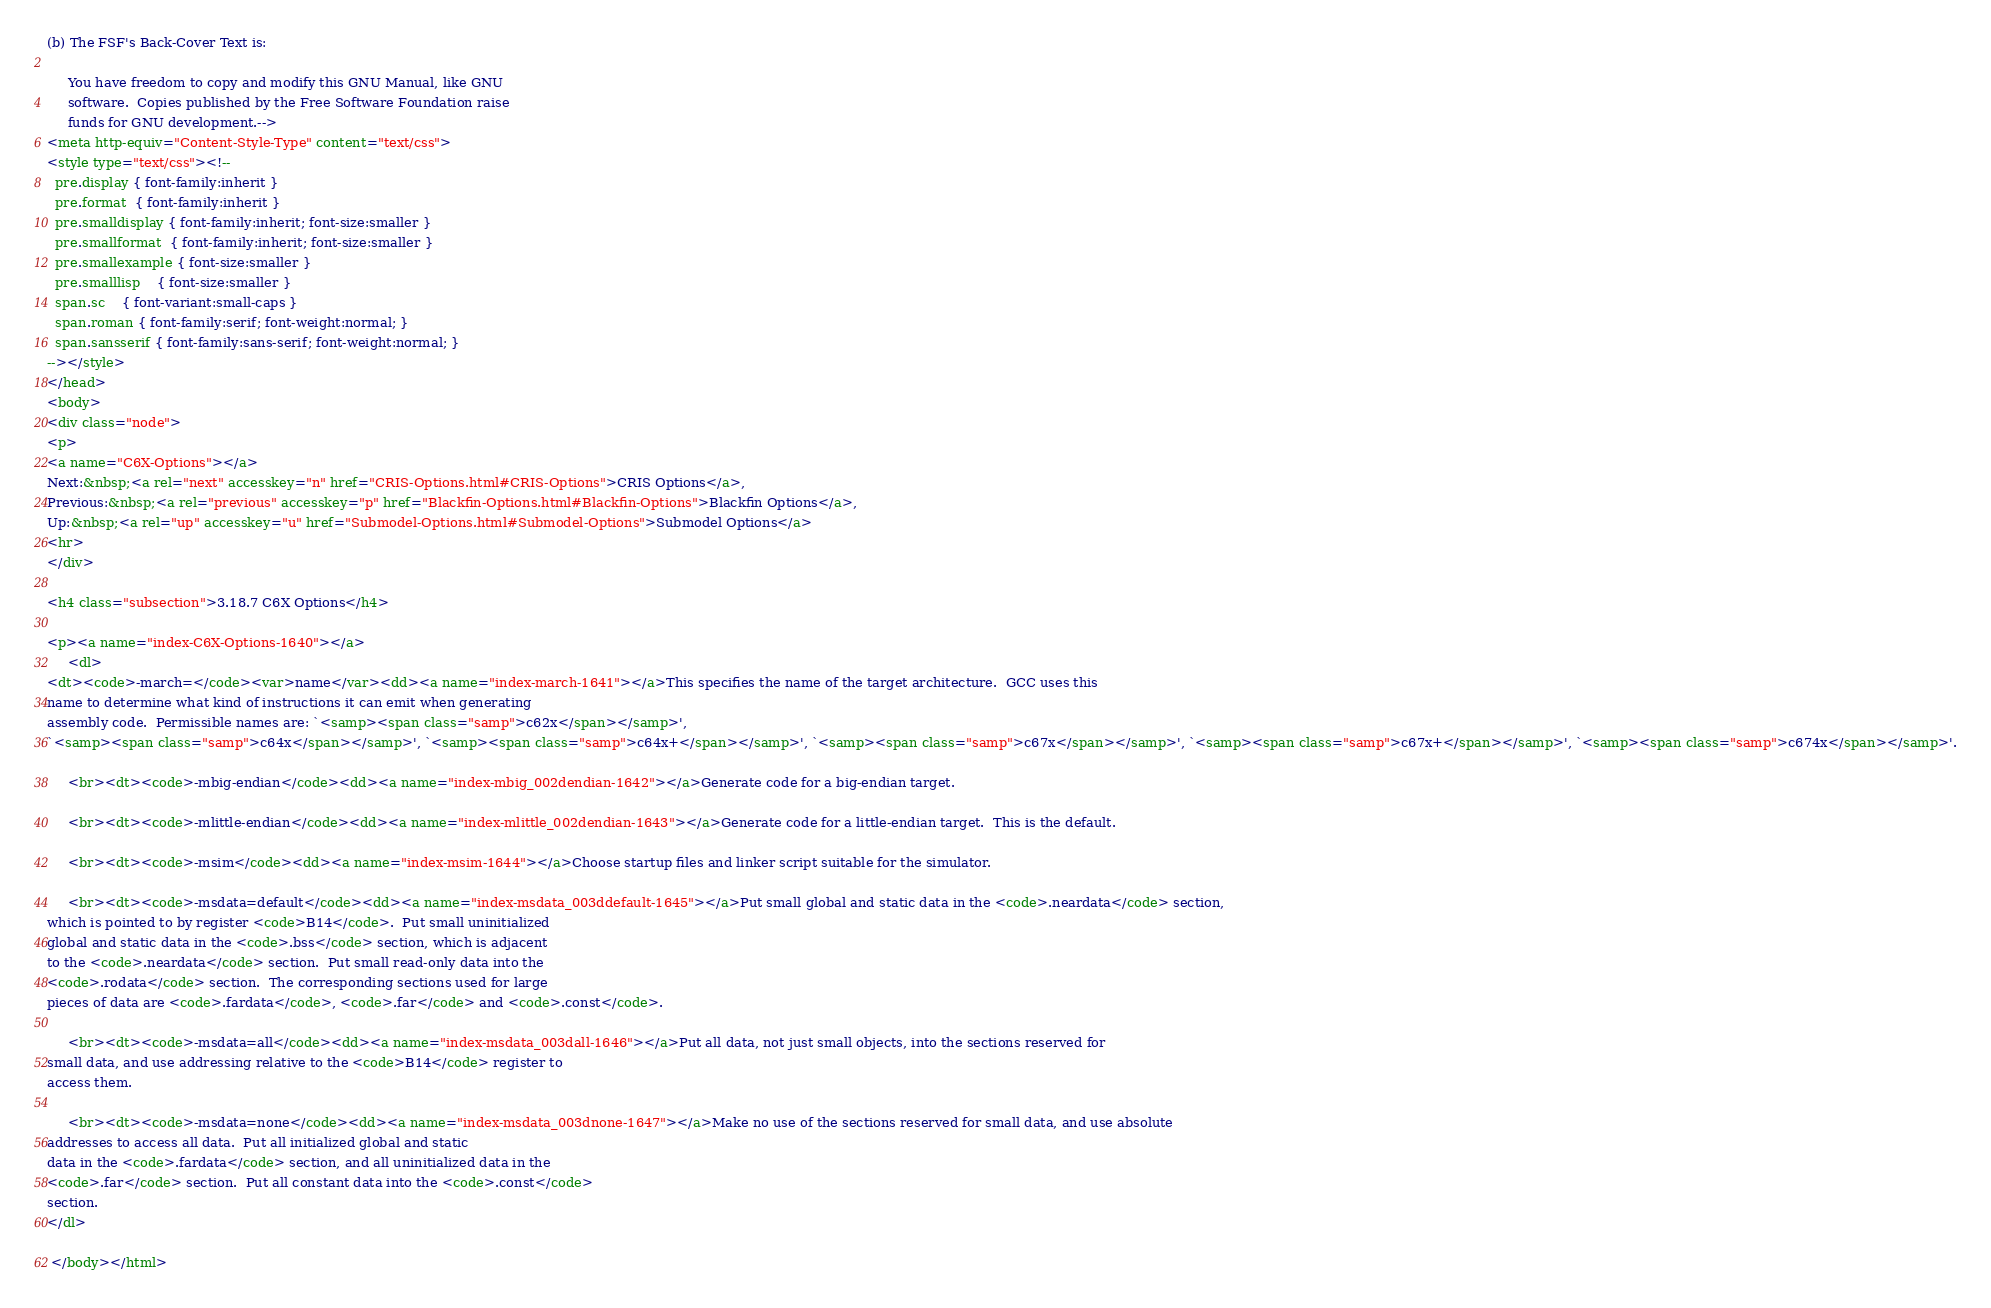Convert code to text. <code><loc_0><loc_0><loc_500><loc_500><_HTML_>
(b) The FSF's Back-Cover Text is:

     You have freedom to copy and modify this GNU Manual, like GNU
     software.  Copies published by the Free Software Foundation raise
     funds for GNU development.-->
<meta http-equiv="Content-Style-Type" content="text/css">
<style type="text/css"><!--
  pre.display { font-family:inherit }
  pre.format  { font-family:inherit }
  pre.smalldisplay { font-family:inherit; font-size:smaller }
  pre.smallformat  { font-family:inherit; font-size:smaller }
  pre.smallexample { font-size:smaller }
  pre.smalllisp    { font-size:smaller }
  span.sc    { font-variant:small-caps }
  span.roman { font-family:serif; font-weight:normal; } 
  span.sansserif { font-family:sans-serif; font-weight:normal; } 
--></style>
</head>
<body>
<div class="node">
<p>
<a name="C6X-Options"></a>
Next:&nbsp;<a rel="next" accesskey="n" href="CRIS-Options.html#CRIS-Options">CRIS Options</a>,
Previous:&nbsp;<a rel="previous" accesskey="p" href="Blackfin-Options.html#Blackfin-Options">Blackfin Options</a>,
Up:&nbsp;<a rel="up" accesskey="u" href="Submodel-Options.html#Submodel-Options">Submodel Options</a>
<hr>
</div>

<h4 class="subsection">3.18.7 C6X Options</h4>

<p><a name="index-C6X-Options-1640"></a>
     <dl>
<dt><code>-march=</code><var>name</var><dd><a name="index-march-1641"></a>This specifies the name of the target architecture.  GCC uses this
name to determine what kind of instructions it can emit when generating
assembly code.  Permissible names are: `<samp><span class="samp">c62x</span></samp>',
`<samp><span class="samp">c64x</span></samp>', `<samp><span class="samp">c64x+</span></samp>', `<samp><span class="samp">c67x</span></samp>', `<samp><span class="samp">c67x+</span></samp>', `<samp><span class="samp">c674x</span></samp>'.

     <br><dt><code>-mbig-endian</code><dd><a name="index-mbig_002dendian-1642"></a>Generate code for a big-endian target.

     <br><dt><code>-mlittle-endian</code><dd><a name="index-mlittle_002dendian-1643"></a>Generate code for a little-endian target.  This is the default.

     <br><dt><code>-msim</code><dd><a name="index-msim-1644"></a>Choose startup files and linker script suitable for the simulator.

     <br><dt><code>-msdata=default</code><dd><a name="index-msdata_003ddefault-1645"></a>Put small global and static data in the <code>.neardata</code> section,
which is pointed to by register <code>B14</code>.  Put small uninitialized
global and static data in the <code>.bss</code> section, which is adjacent
to the <code>.neardata</code> section.  Put small read-only data into the
<code>.rodata</code> section.  The corresponding sections used for large
pieces of data are <code>.fardata</code>, <code>.far</code> and <code>.const</code>.

     <br><dt><code>-msdata=all</code><dd><a name="index-msdata_003dall-1646"></a>Put all data, not just small objects, into the sections reserved for
small data, and use addressing relative to the <code>B14</code> register to
access them.

     <br><dt><code>-msdata=none</code><dd><a name="index-msdata_003dnone-1647"></a>Make no use of the sections reserved for small data, and use absolute
addresses to access all data.  Put all initialized global and static
data in the <code>.fardata</code> section, and all uninitialized data in the
<code>.far</code> section.  Put all constant data into the <code>.const</code>
section. 
</dl>

 </body></html>

</code> 